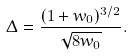Convert formula to latex. <formula><loc_0><loc_0><loc_500><loc_500>\Delta = \frac { ( 1 + w _ { 0 } ) ^ { 3 / 2 } } { \sqrt { 8 w _ { 0 } } } .</formula> 